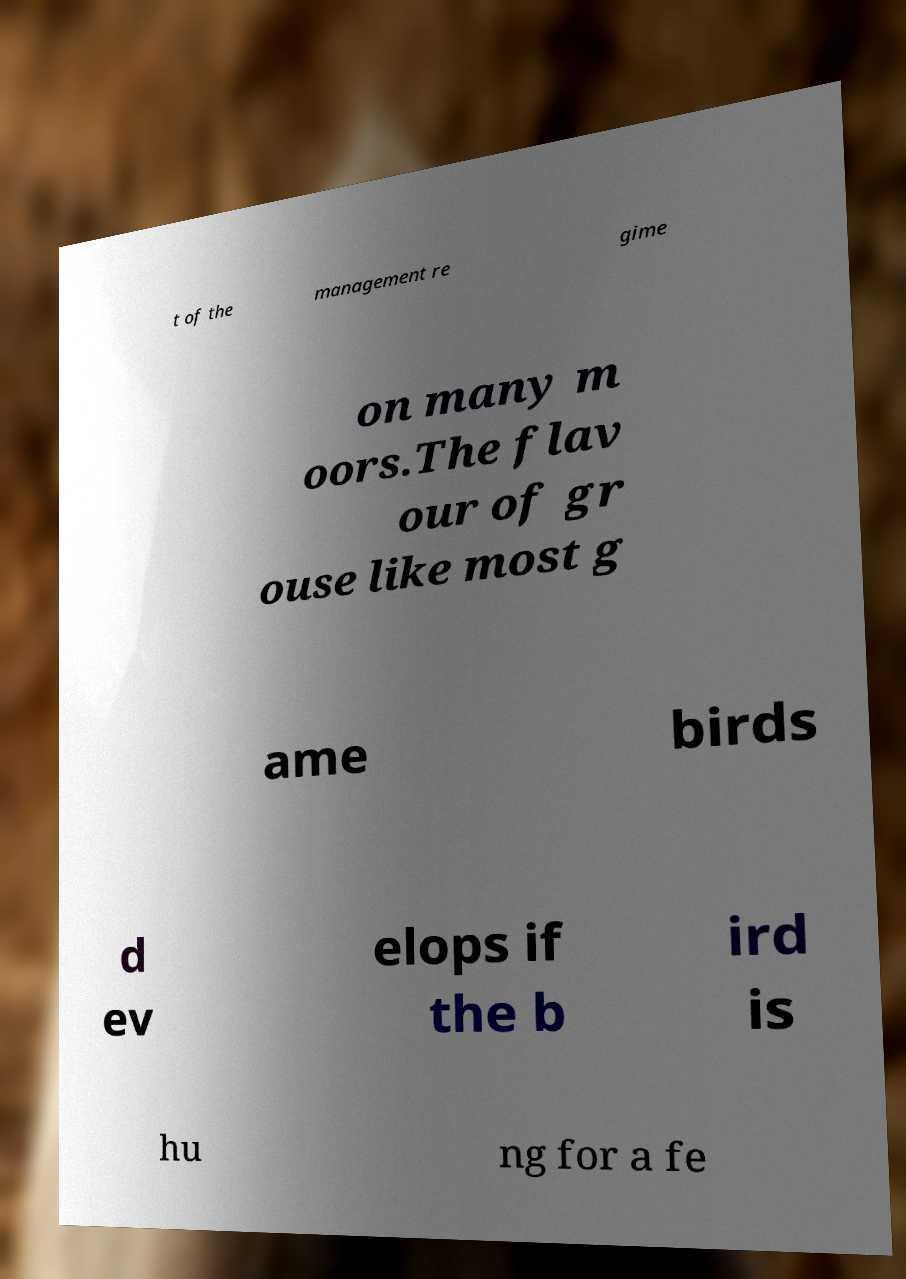Can you read and provide the text displayed in the image?This photo seems to have some interesting text. Can you extract and type it out for me? t of the management re gime on many m oors.The flav our of gr ouse like most g ame birds d ev elops if the b ird is hu ng for a fe 